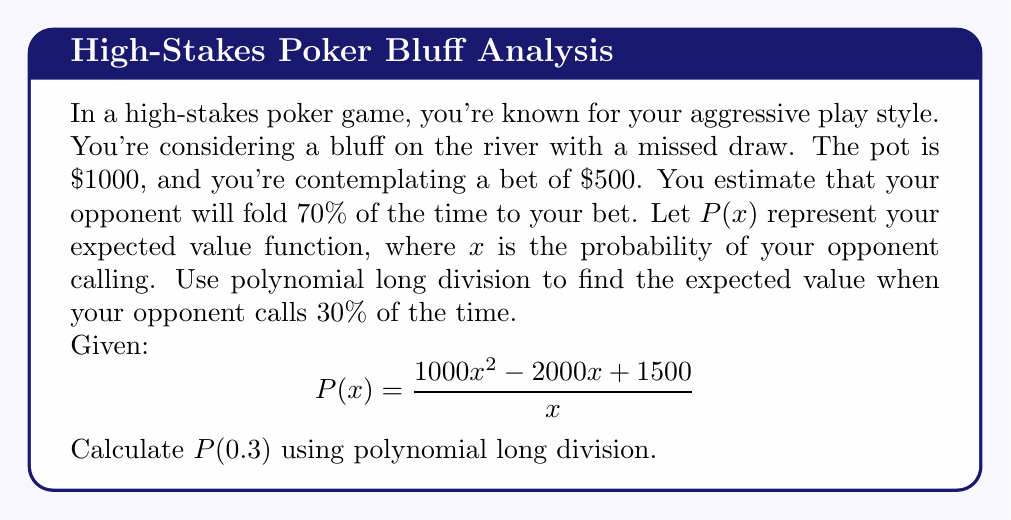Can you answer this question? To solve this problem, we need to perform polynomial long division and then evaluate the result at $x = 0.3$. Let's break it down step-by-step:

1) First, let's set up the polynomial long division:

   $$\frac{1000x^2 - 2000x + 1500}{x}$$

2) Divide $1000x^2$ by $x$:
   $$1000x - 2000x + 1500$$
   
3) Bring down the next term:
   $$1000x - 2000 + \frac{1500}{x}$$

4) So, after polynomial long division, we get:
   $$P(x) = 1000x - 2000 + \frac{1500}{x}$$

5) Now, we need to evaluate this at $x = 0.3$:
   $$P(0.3) = 1000(0.3) - 2000 + \frac{1500}{0.3}$$

6) Let's calculate each part:
   - $1000(0.3) = 300$
   - $\frac{1500}{0.3} = 5000$

7) Putting it all together:
   $$P(0.3) = 300 - 2000 + 5000 = 3300$$

Therefore, your expected value when your opponent calls 30% of the time is $3300.
Answer: $3300 